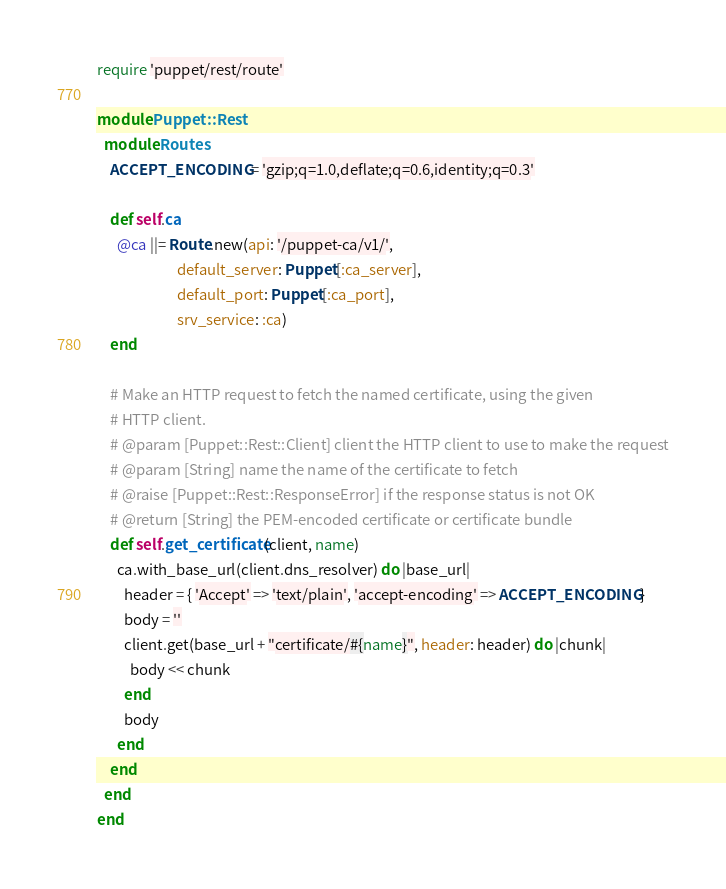Convert code to text. <code><loc_0><loc_0><loc_500><loc_500><_Ruby_>require 'puppet/rest/route'

module Puppet::Rest
  module Routes
    ACCEPT_ENCODING = 'gzip;q=1.0,deflate;q=0.6,identity;q=0.3'

    def self.ca
      @ca ||= Route.new(api: '/puppet-ca/v1/',
                        default_server: Puppet[:ca_server],
                        default_port: Puppet[:ca_port],
                        srv_service: :ca)
    end

    # Make an HTTP request to fetch the named certificate, using the given
    # HTTP client.
    # @param [Puppet::Rest::Client] client the HTTP client to use to make the request
    # @param [String] name the name of the certificate to fetch
    # @raise [Puppet::Rest::ResponseError] if the response status is not OK
    # @return [String] the PEM-encoded certificate or certificate bundle
    def self.get_certificate(client, name)
      ca.with_base_url(client.dns_resolver) do |base_url|
        header = { 'Accept' => 'text/plain', 'accept-encoding' => ACCEPT_ENCODING }
        body = ''
        client.get(base_url + "certificate/#{name}", header: header) do |chunk|
          body << chunk
        end
        body
      end
    end
  end
end
</code> 